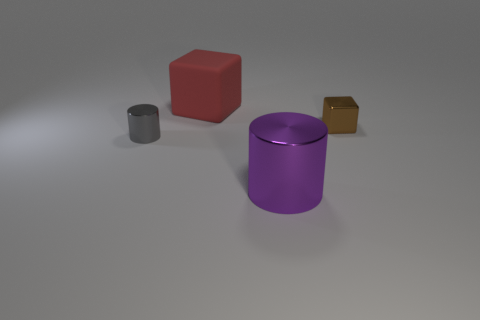The small block is what color?
Give a very brief answer. Brown. Are there any tiny things left of the brown metallic thing?
Ensure brevity in your answer.  Yes. Do the small block and the tiny shiny cylinder have the same color?
Provide a succinct answer. No. What is the size of the shiny cylinder right of the block that is on the left side of the brown metallic object?
Your response must be concise. Large. What is the shape of the tiny brown object?
Make the answer very short. Cube. What is the material of the large thing that is in front of the gray shiny cylinder?
Provide a short and direct response. Metal. There is a cylinder that is in front of the cylinder on the left side of the cube that is left of the tiny metallic block; what is its color?
Make the answer very short. Purple. There is another object that is the same size as the purple thing; what is its color?
Offer a terse response. Red. What number of metal things are either red things or tiny things?
Keep it short and to the point. 2. The block that is made of the same material as the purple thing is what color?
Your answer should be compact. Brown. 